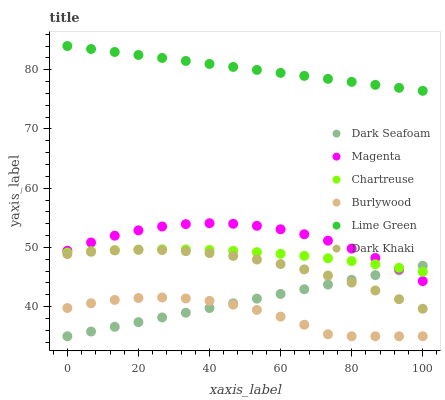Does Burlywood have the minimum area under the curve?
Answer yes or no. Yes. Does Lime Green have the maximum area under the curve?
Answer yes or no. Yes. Does Chartreuse have the minimum area under the curve?
Answer yes or no. No. Does Chartreuse have the maximum area under the curve?
Answer yes or no. No. Is Dark Seafoam the smoothest?
Answer yes or no. Yes. Is Burlywood the roughest?
Answer yes or no. Yes. Is Chartreuse the smoothest?
Answer yes or no. No. Is Chartreuse the roughest?
Answer yes or no. No. Does Burlywood have the lowest value?
Answer yes or no. Yes. Does Chartreuse have the lowest value?
Answer yes or no. No. Does Lime Green have the highest value?
Answer yes or no. Yes. Does Chartreuse have the highest value?
Answer yes or no. No. Is Dark Seafoam less than Lime Green?
Answer yes or no. Yes. Is Magenta greater than Dark Khaki?
Answer yes or no. Yes. Does Chartreuse intersect Magenta?
Answer yes or no. Yes. Is Chartreuse less than Magenta?
Answer yes or no. No. Is Chartreuse greater than Magenta?
Answer yes or no. No. Does Dark Seafoam intersect Lime Green?
Answer yes or no. No. 